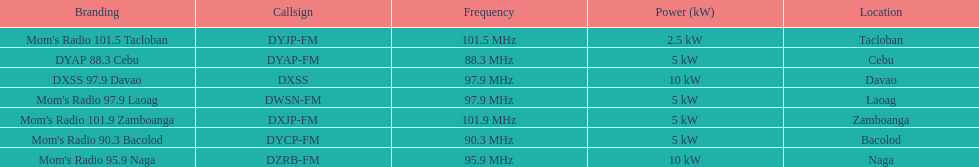Which of these stations broadcasts with the least power? Mom's Radio 101.5 Tacloban. 